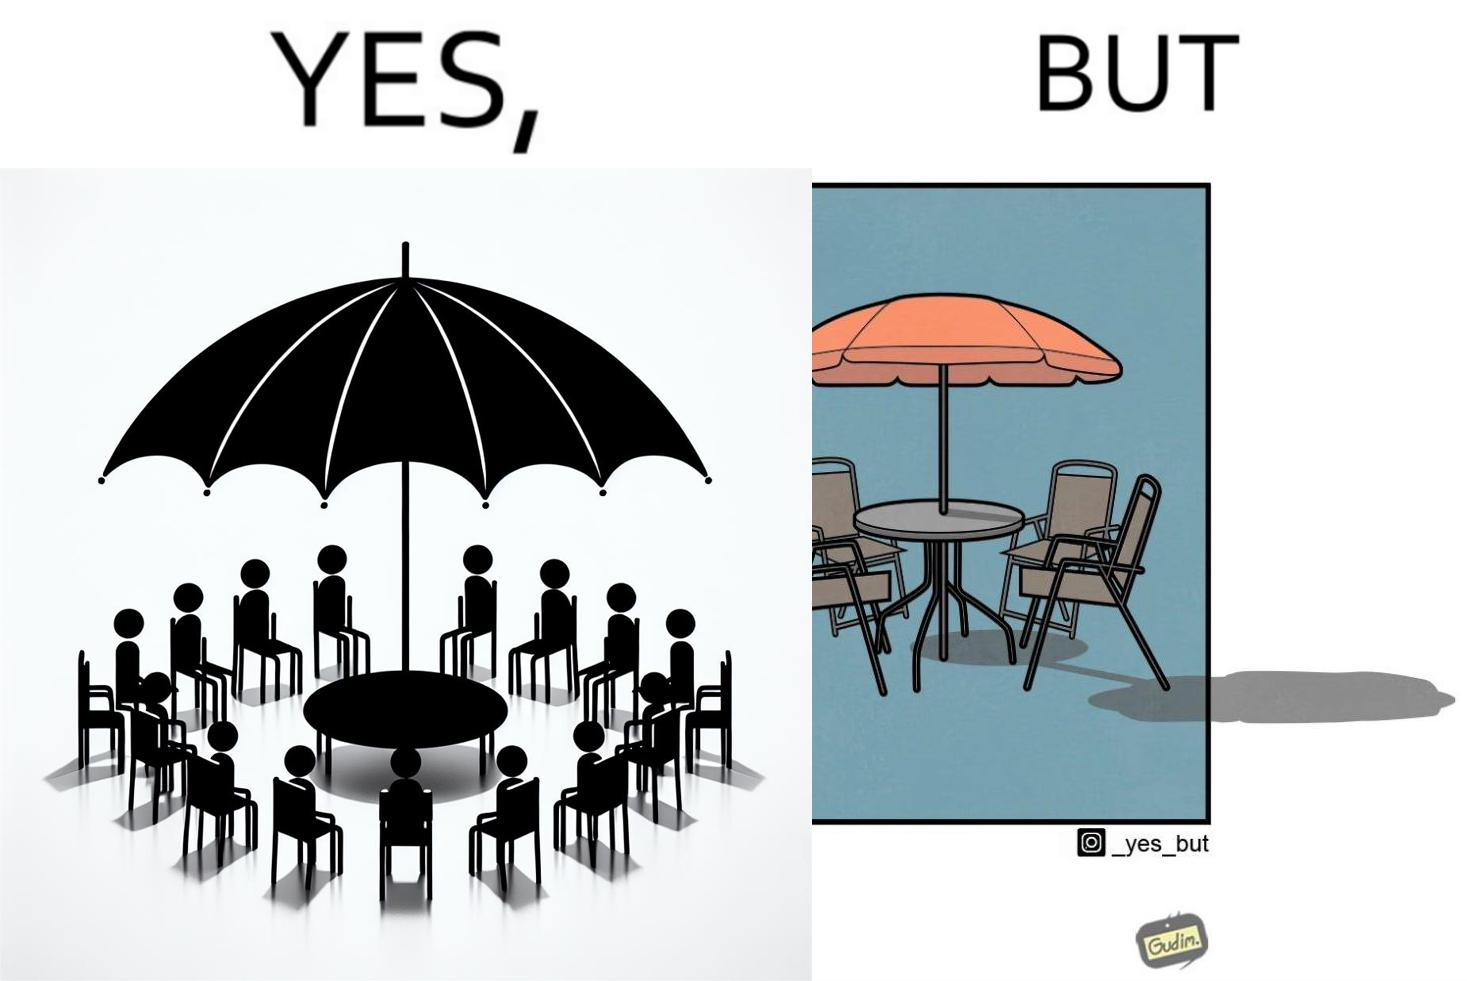Describe what you see in this image. The image is ironical, as the umbrella is meant to provide shadow in the area where the chairs are present, but due to the orientation of the rays of the sun, all the chairs are in sunlight, and the umbrella is of no use in this situation. 